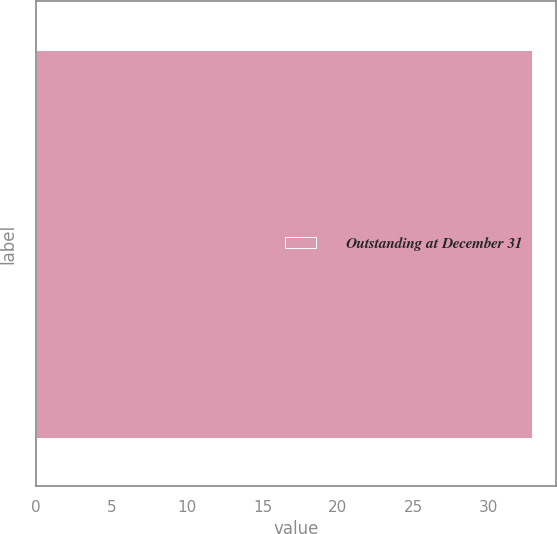Convert chart. <chart><loc_0><loc_0><loc_500><loc_500><bar_chart><fcel>Outstanding at December 31<nl><fcel>32.84<nl></chart> 